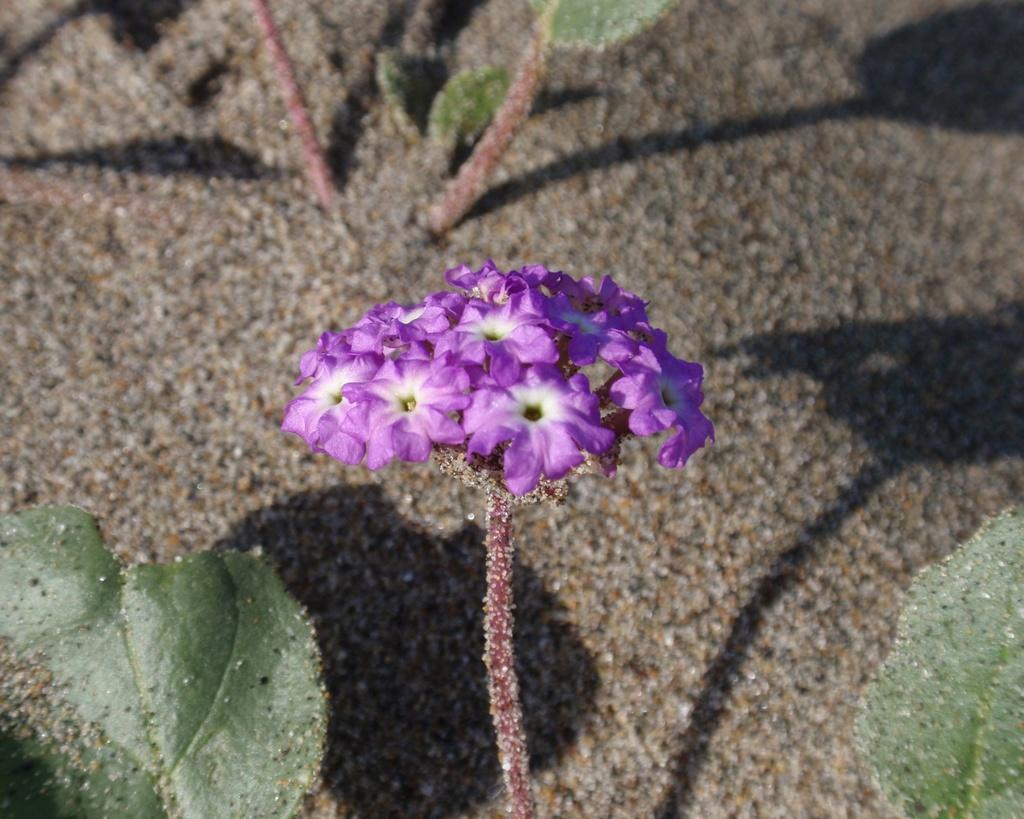What is located in the middle of the image? There are flowers in the middle of the image. What can be seen at the bottom of the image? There are leaves at the bottom of the image. What is present at the top of the image? There are leaves at the top of the image. What type of noise can be heard coming from the alley in the image? There is no alley present in the image, so it is not possible to determine what, if any, noise might be heard. 